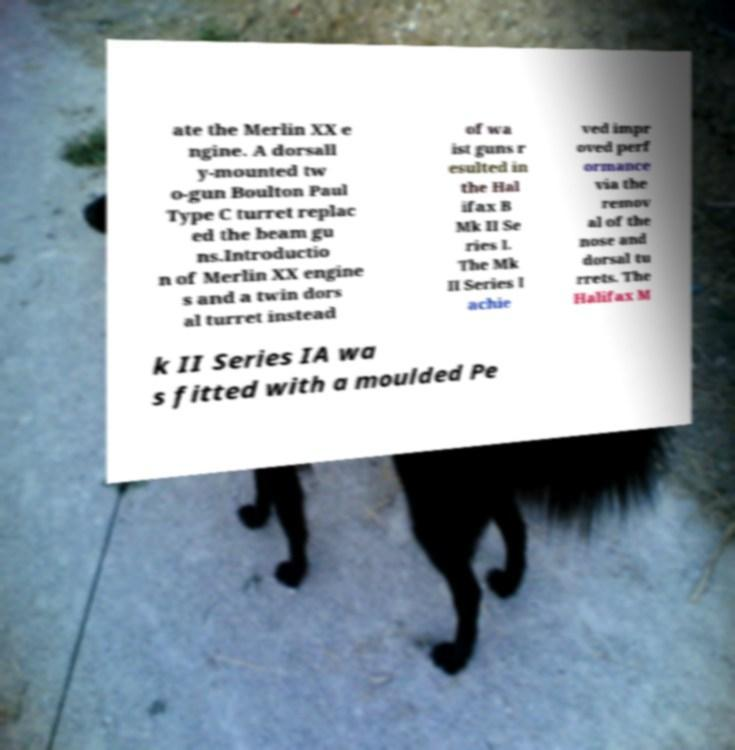Could you assist in decoding the text presented in this image and type it out clearly? ate the Merlin XX e ngine. A dorsall y-mounted tw o-gun Boulton Paul Type C turret replac ed the beam gu ns.Introductio n of Merlin XX engine s and a twin dors al turret instead of wa ist guns r esulted in the Hal ifax B Mk II Se ries I. The Mk II Series I achie ved impr oved perf ormance via the remov al of the nose and dorsal tu rrets. The Halifax M k II Series IA wa s fitted with a moulded Pe 